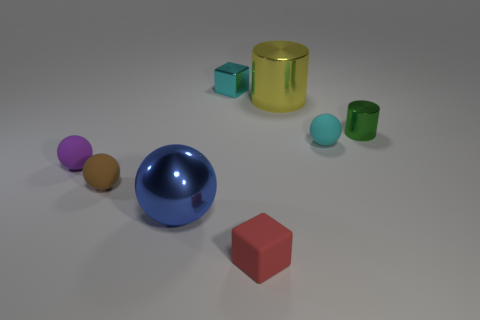What number of other objects are there of the same shape as the brown matte thing?
Your answer should be very brief. 3. How big is the metal object that is in front of the matte sphere right of the large object in front of the purple rubber object?
Make the answer very short. Large. How many blue objects are large spheres or matte blocks?
Keep it short and to the point. 1. There is a large object that is behind the brown matte thing to the left of the tiny cyan matte object; what shape is it?
Offer a very short reply. Cylinder. Is the size of the shiny cylinder that is on the left side of the green shiny cylinder the same as the shiny thing in front of the small green object?
Offer a terse response. Yes. Are there any spheres made of the same material as the small brown object?
Make the answer very short. Yes. There is a small metallic object that is on the right side of the tiny shiny object that is behind the green shiny thing; are there any blue metallic spheres that are left of it?
Ensure brevity in your answer.  Yes. There is a tiny red matte object; are there any small metal objects right of it?
Your answer should be compact. Yes. What number of small matte things are in front of the matte ball that is on the right side of the yellow metallic thing?
Your answer should be very brief. 3. Does the brown object have the same size as the cyan thing to the left of the cyan matte object?
Offer a terse response. Yes. 